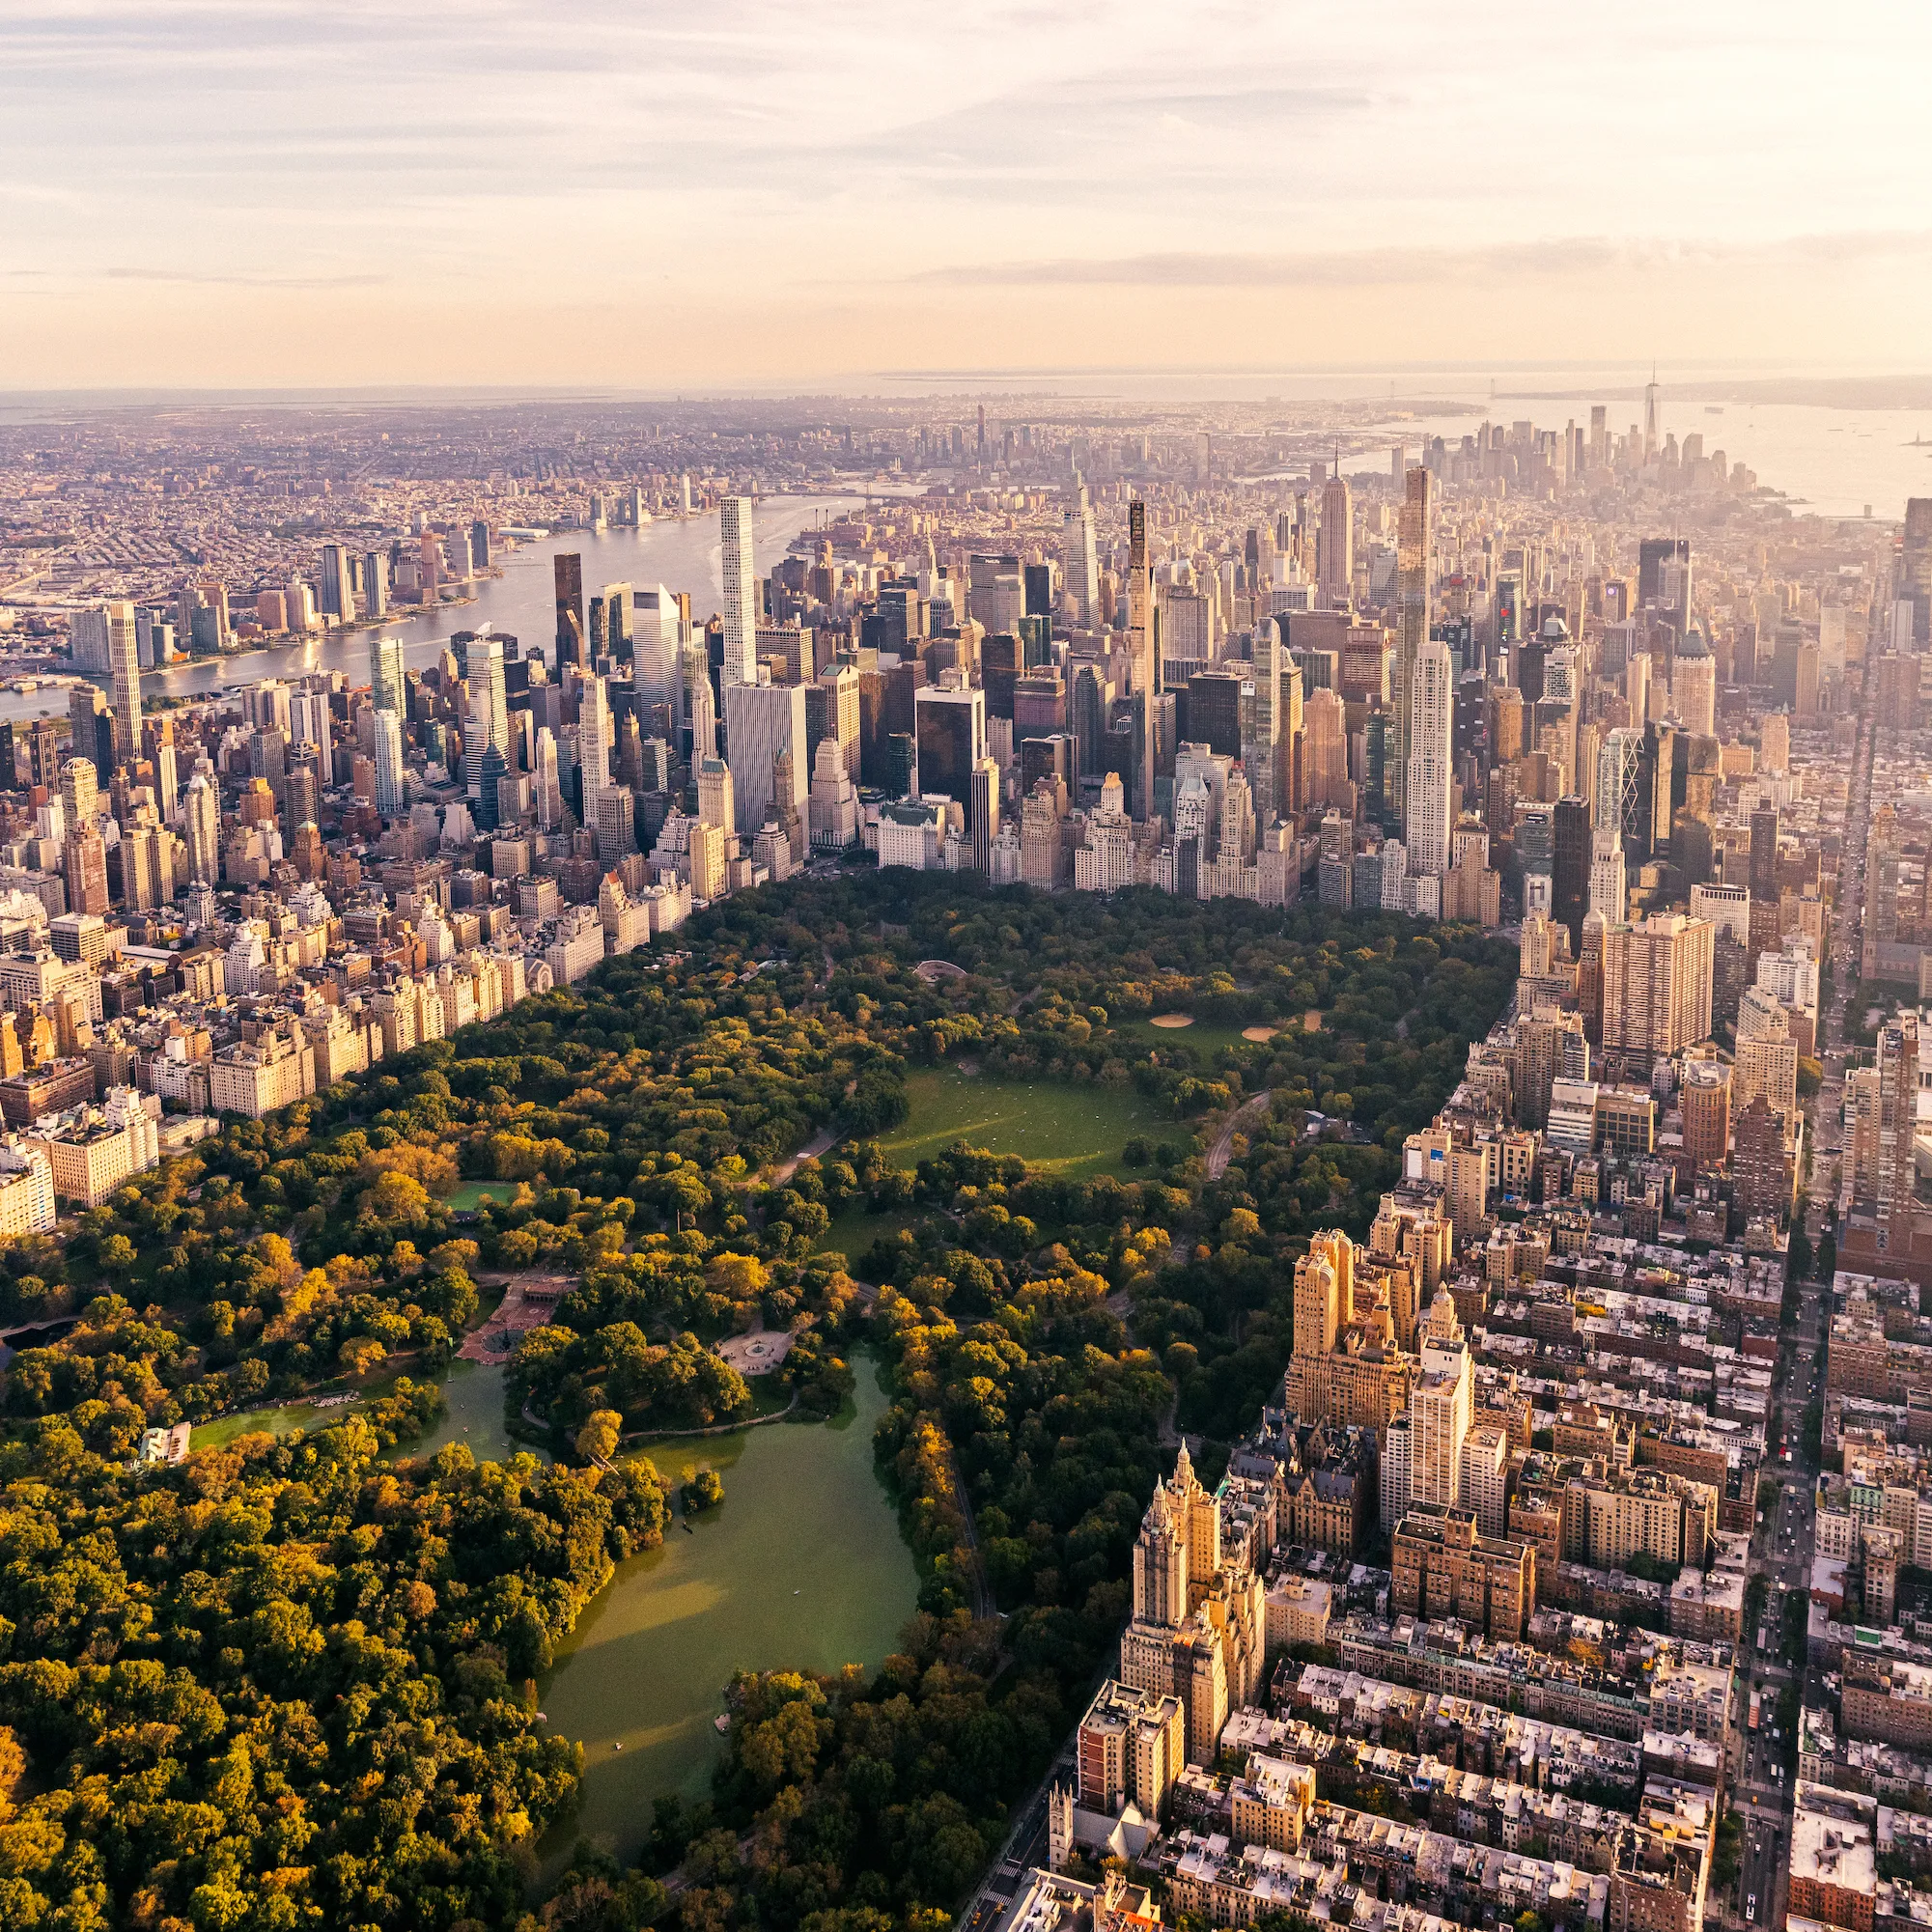Can you discuss the architectural styles visible around Central Park? Around Central Park, you can observe a fascinating mix of architectural styles. To the south and west of the park, modern skyscrapers dominate the skyline, showcasing glass and steel construction typical of contemporary design. In contrast, the areas to the north and east often feature older, more historic buildings with Gothic, Art Deco, and Beaux-Arts elements. This architectural diversity not only reflects the city's historical development but also adds to the unique aesthetic character of the park's urban backdrop. What role does Central Park play in the ecological and cultural life of the city? Central Park serves as a vital green lung for New York City, offering both ecological benefits like improving air quality and providing a habitat for wildlife, and cultural benefits by hosting numerous events, performances, and art installations. It is a center for community gathering and recreation that enhances the quality of life for city residents, making it an invaluable asset in both an ecological and cultural sense. 